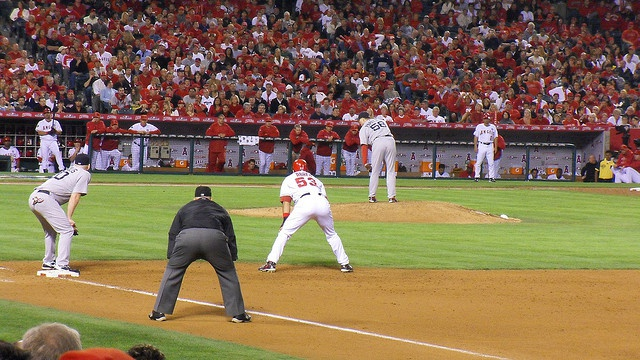Describe the objects in this image and their specific colors. I can see people in gray, black, maroon, and olive tones, people in gray, black, and tan tones, people in gray, white, olive, darkgray, and tan tones, people in gray, lavender, darkgray, and olive tones, and people in gray, lavender, violet, and darkgray tones in this image. 